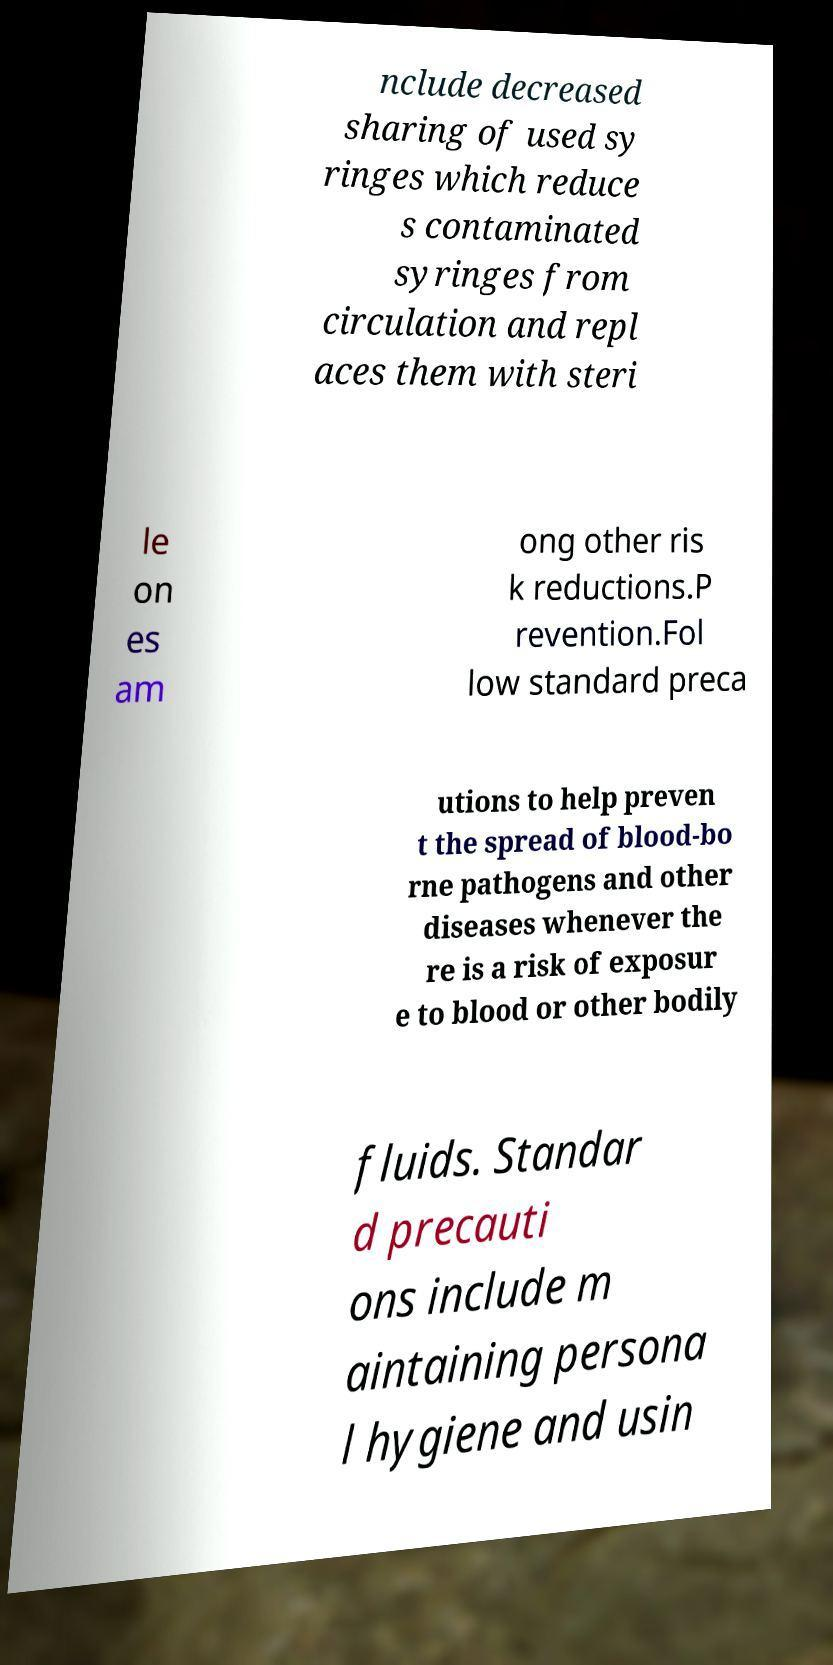Can you accurately transcribe the text from the provided image for me? nclude decreased sharing of used sy ringes which reduce s contaminated syringes from circulation and repl aces them with steri le on es am ong other ris k reductions.P revention.Fol low standard preca utions to help preven t the spread of blood-bo rne pathogens and other diseases whenever the re is a risk of exposur e to blood or other bodily fluids. Standar d precauti ons include m aintaining persona l hygiene and usin 